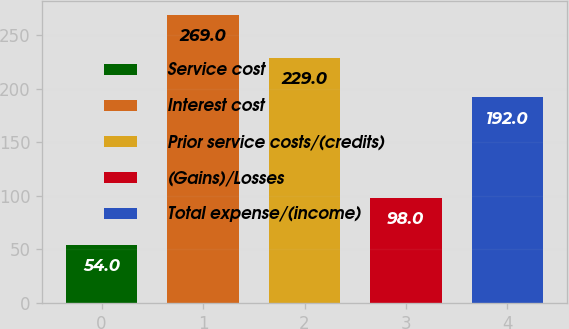Convert chart to OTSL. <chart><loc_0><loc_0><loc_500><loc_500><bar_chart><fcel>Service cost<fcel>Interest cost<fcel>Prior service costs/(credits)<fcel>(Gains)/Losses<fcel>Total expense/(income)<nl><fcel>54<fcel>269<fcel>229<fcel>98<fcel>192<nl></chart> 